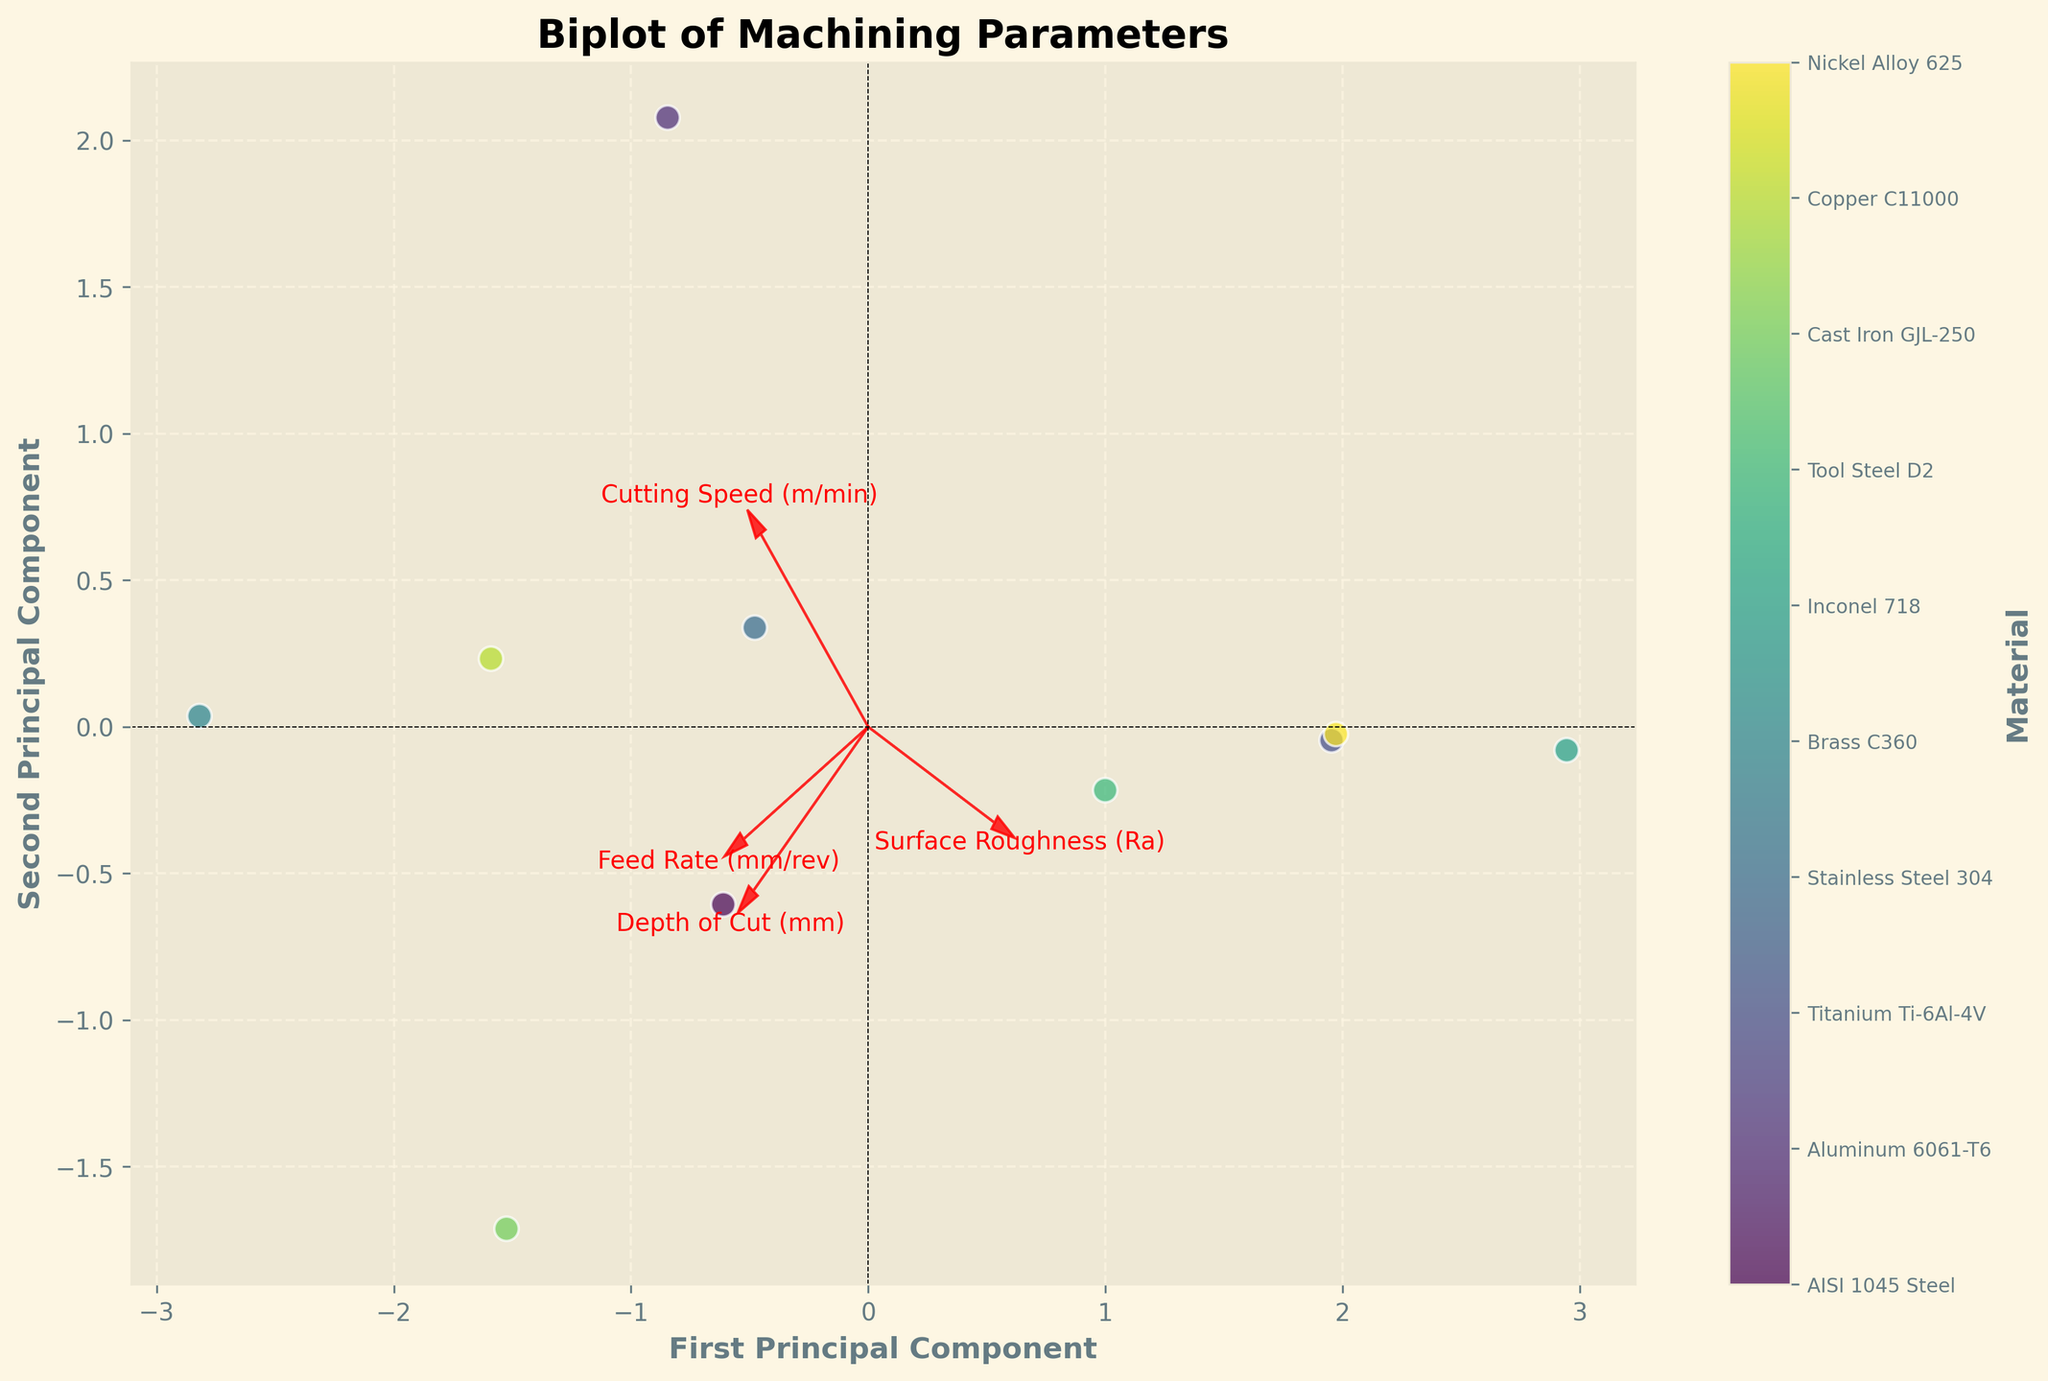How many materials are represented in the biplot? The number of data points on the biplot corresponds to the number of materials. By counting them, we see there are ten distinct points each representing a different material.
Answer: Ten What do the arrows in the biplot represent? In the biplot, arrows represent the original features (machining parameters) including Surface Roughness (Ra), Cutting Speed, Feed Rate, and Depth of Cut. The direction and length of each arrow depict the influence and variance of that particular parameter on the principal components.
Answer: Machining parameters Which machining parameter has the largest influence on the first principal component? To determine this, we look at the length and direction of the arrows in the biplot along the first principal component (X-axis). The arrow for 'Cutting Speed' extends farthest in the horizontal direction, indicating it has the largest influence on the first principal component.
Answer: Cutting Speed Which machining parameter contributes the least to the second principal component? By examining the direction and length of the arrows relative to the second principal component (Y-axis), we see 'Depth of Cut' has the smallest projection along this axis, suggesting it contributes the least to the second principal component.
Answer: Depth of Cut Which materials are closest together on the biplot, indicating similar machining characteristics? On the biplot, the distance between points represents the similarity of their machining characteristics. 'Stainless Steel 304' and 'Copper C11000' are plotted close to each other, indicating their machining characteristics are similar.
Answer: Stainless Steel 304 and Copper C11000 Which material is least similar to Brass C360 based on their position in the biplot? To find this, we look for the material farthest from Brass C360 on the biplot. 'Inconel 718' is positioned the farthest from Brass C360, indicating it is the least similar in machining characteristics.
Answer: Inconel 718 What general trend does the plot indicate regarding Cutting Speed and Surface Roughness? Looking at the directions of the Cutting Speed and Surface Roughness arrows, they are orthogonal, or nearly perpendicular, indicating there is no significant correlation between Cutting Speed and Surface Roughness.
Answer: No significant correlation Based on the biplot, which machining parameter shows the highest correlation with Surface Roughness (Ra)? To answer, we observe the arrows for Surface Roughness and other machining parameters. The arrows for Surface Roughness and 'Feed Rate' are nearly parallel, indicating a high correlation between them.
Answer: Feed Rate Which principal component explains more variance in the data, and how can you tell? The biplot helps by showing the length of the axes for the principal components. The axis for the first principal component is usually longer and accounts for more variance in the data compared to the second component. This is corroborated by the larger space covered along the X-axis in the plot.
Answer: First Principal Component 